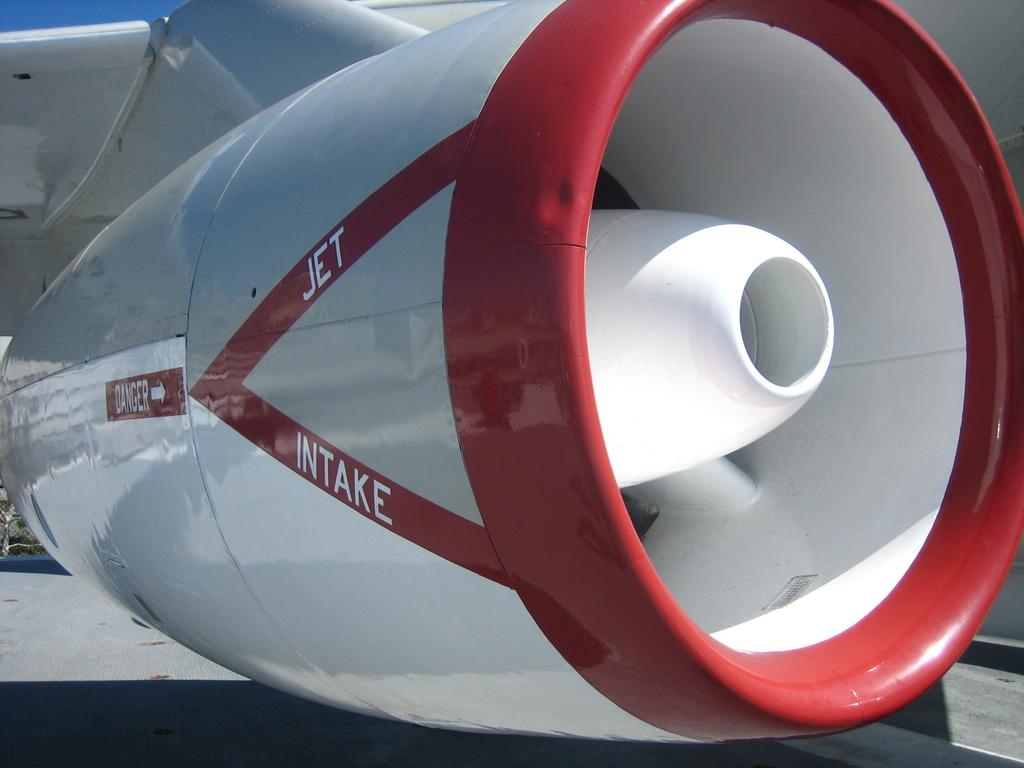What is written on the red strip on the bottom?
Your answer should be compact. Intake. 